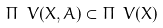<formula> <loc_0><loc_0><loc_500><loc_500>\Pi _ { \ } V ( X , A ) \subset \Pi _ { \ } V ( X )</formula> 